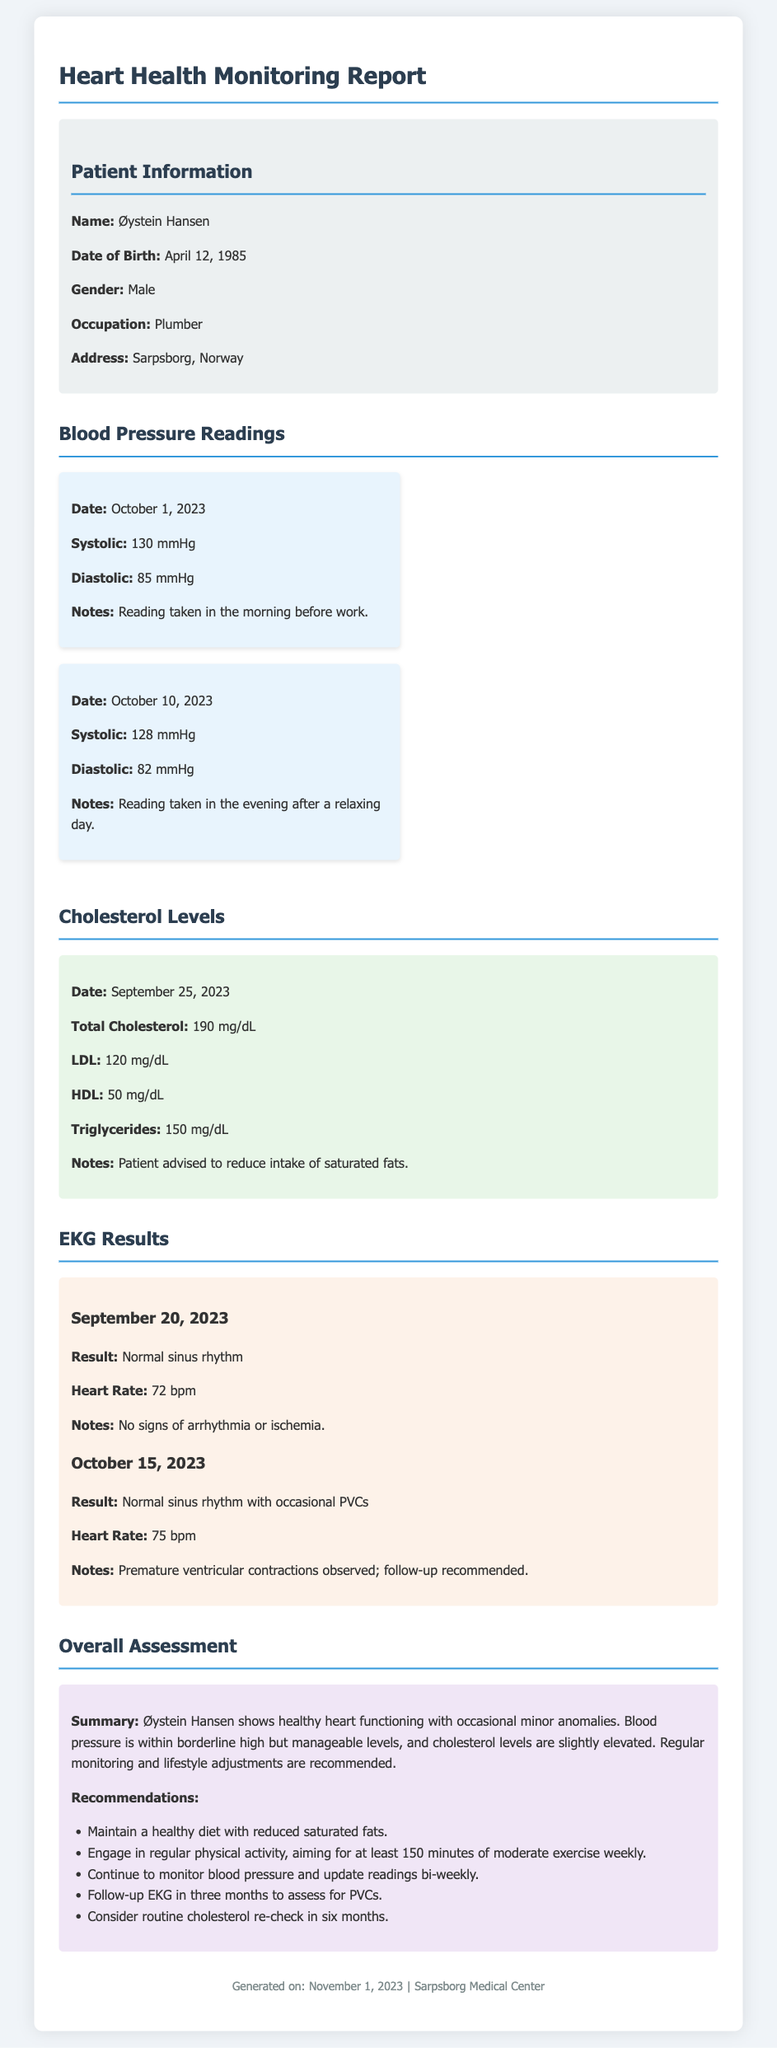What is the patient's name? The document provides the patient's name at the top of the patient information section.
Answer: Øystein Hansen What is the date of the latest blood pressure reading? The latest blood pressure reading is listed under the blood pressure readings section with its corresponding date.
Answer: October 10, 2023 What is the result of the EKG on September 20, 2023? The EKG result section contains the findings for each date.
Answer: Normal sinus rhythm What is the total cholesterol level recorded? The total cholesterol level is specified in the cholesterol levels section.
Answer: 190 mg/dL What is the patient's heart rate during the EKG on October 15, 2023? The heart rate is provided in the EKG results section along with the date.
Answer: 75 bpm What lifestyle change is recommended regarding diet? The recommendations section includes advice about dietary adjustments.
Answer: Reduce saturated fats What should be the follow-up time for the EKG to assess PVCs? The overall assessment includes a follow-up recommendation timeframe for the EKG.
Answer: Three months What were the diastolic blood pressure readings on October 1, 2023? The blood pressure reading section lists both systolic and diastolic values for that date.
Answer: 85 mmHg What is the occupation of the patient? The patient's occupation is noted in the patient information section.
Answer: Plumber 